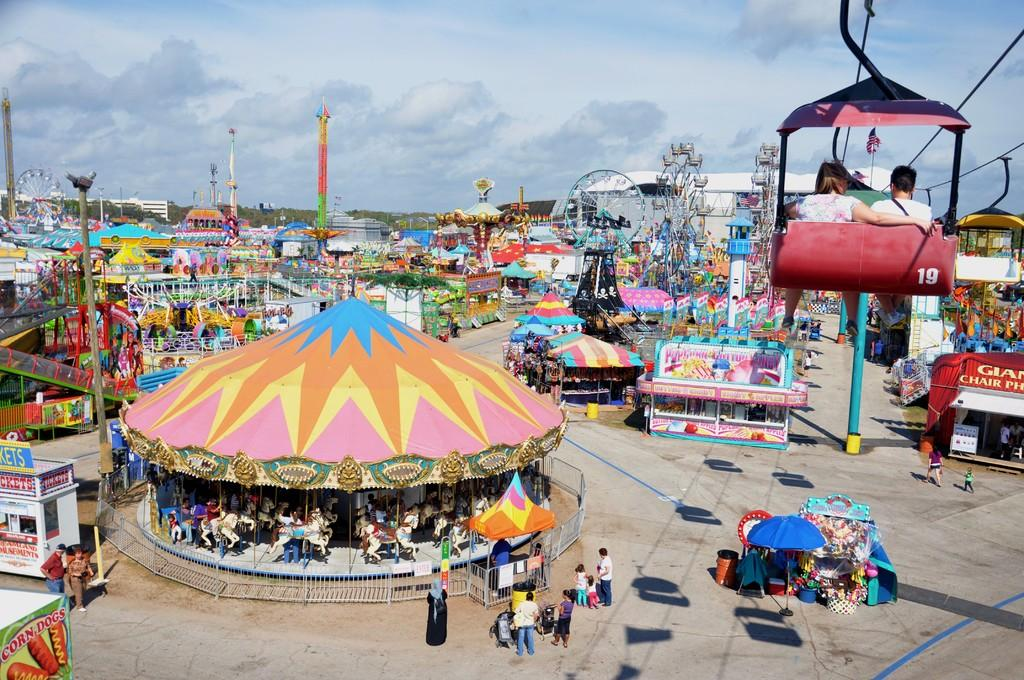What type of event is depicted in the image? The image is of an exhibition. What attractions can be seen at the exhibition? There are rides in the image. What structures are present at the exhibition? There are poles, stalls, and boards in the image. Are there any people attending the exhibition? Yes, there are people in the image. What safety features are present at the exhibition? There are railings in the image. What is the weather like at the exhibition? The sky is visible at the top of the image and appears to be cloudy. Can you see any rabbits hopping around in the image? No, there are no rabbits present in the image. Is there a ship docked at the exhibition in the image? No, there is no ship present in the image. 